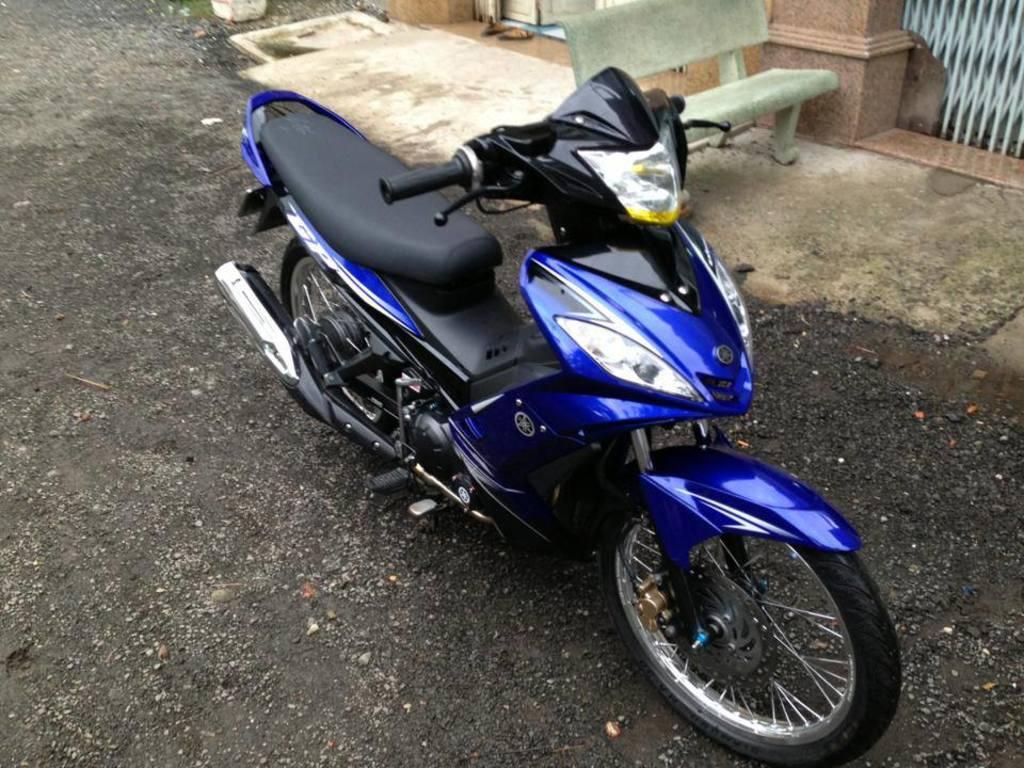Can you describe this image briefly? Here in this picture we can see a blue and black colored motorbike present on the road and beside that we can see a bench present and we can also see a gate present beside that. 